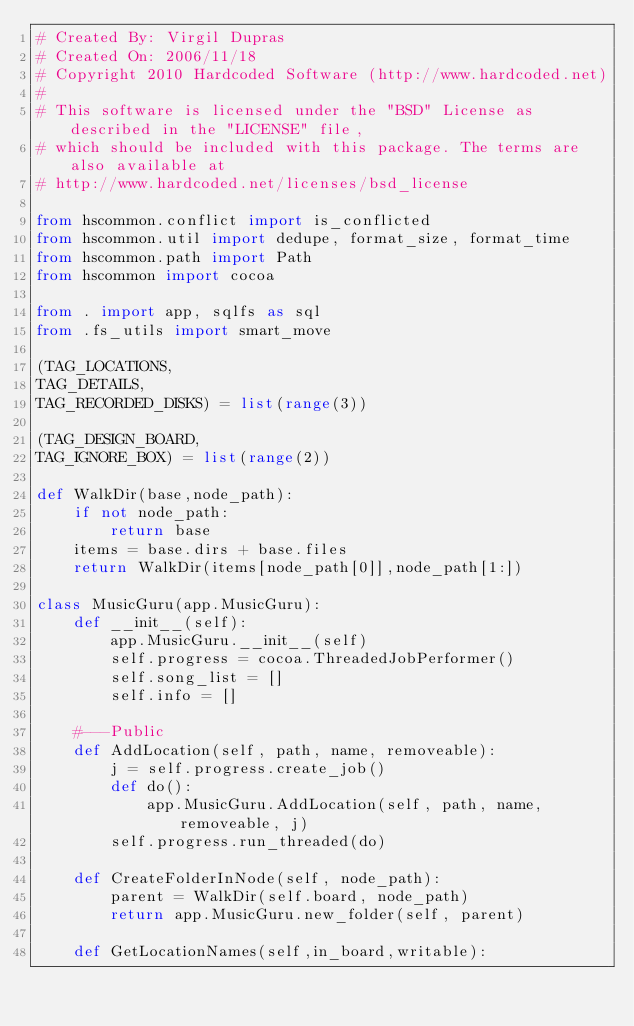Convert code to text. <code><loc_0><loc_0><loc_500><loc_500><_Python_># Created By: Virgil Dupras
# Created On: 2006/11/18
# Copyright 2010 Hardcoded Software (http://www.hardcoded.net)
# 
# This software is licensed under the "BSD" License as described in the "LICENSE" file, 
# which should be included with this package. The terms are also available at 
# http://www.hardcoded.net/licenses/bsd_license

from hscommon.conflict import is_conflicted
from hscommon.util import dedupe, format_size, format_time
from hscommon.path import Path
from hscommon import cocoa

from . import app, sqlfs as sql
from .fs_utils import smart_move

(TAG_LOCATIONS,
TAG_DETAILS,
TAG_RECORDED_DISKS) = list(range(3))

(TAG_DESIGN_BOARD,
TAG_IGNORE_BOX) = list(range(2))

def WalkDir(base,node_path):
    if not node_path:
        return base
    items = base.dirs + base.files
    return WalkDir(items[node_path[0]],node_path[1:])
    
class MusicGuru(app.MusicGuru):
    def __init__(self):
        app.MusicGuru.__init__(self)
        self.progress = cocoa.ThreadedJobPerformer()
        self.song_list = []
        self.info = []
    
    #---Public
    def AddLocation(self, path, name, removeable):
        j = self.progress.create_job()
        def do():
            app.MusicGuru.AddLocation(self, path, name, removeable, j)
        self.progress.run_threaded(do)
    
    def CreateFolderInNode(self, node_path):
        parent = WalkDir(self.board, node_path)
        return app.MusicGuru.new_folder(self, parent)
    
    def GetLocationNames(self,in_board,writable):</code> 